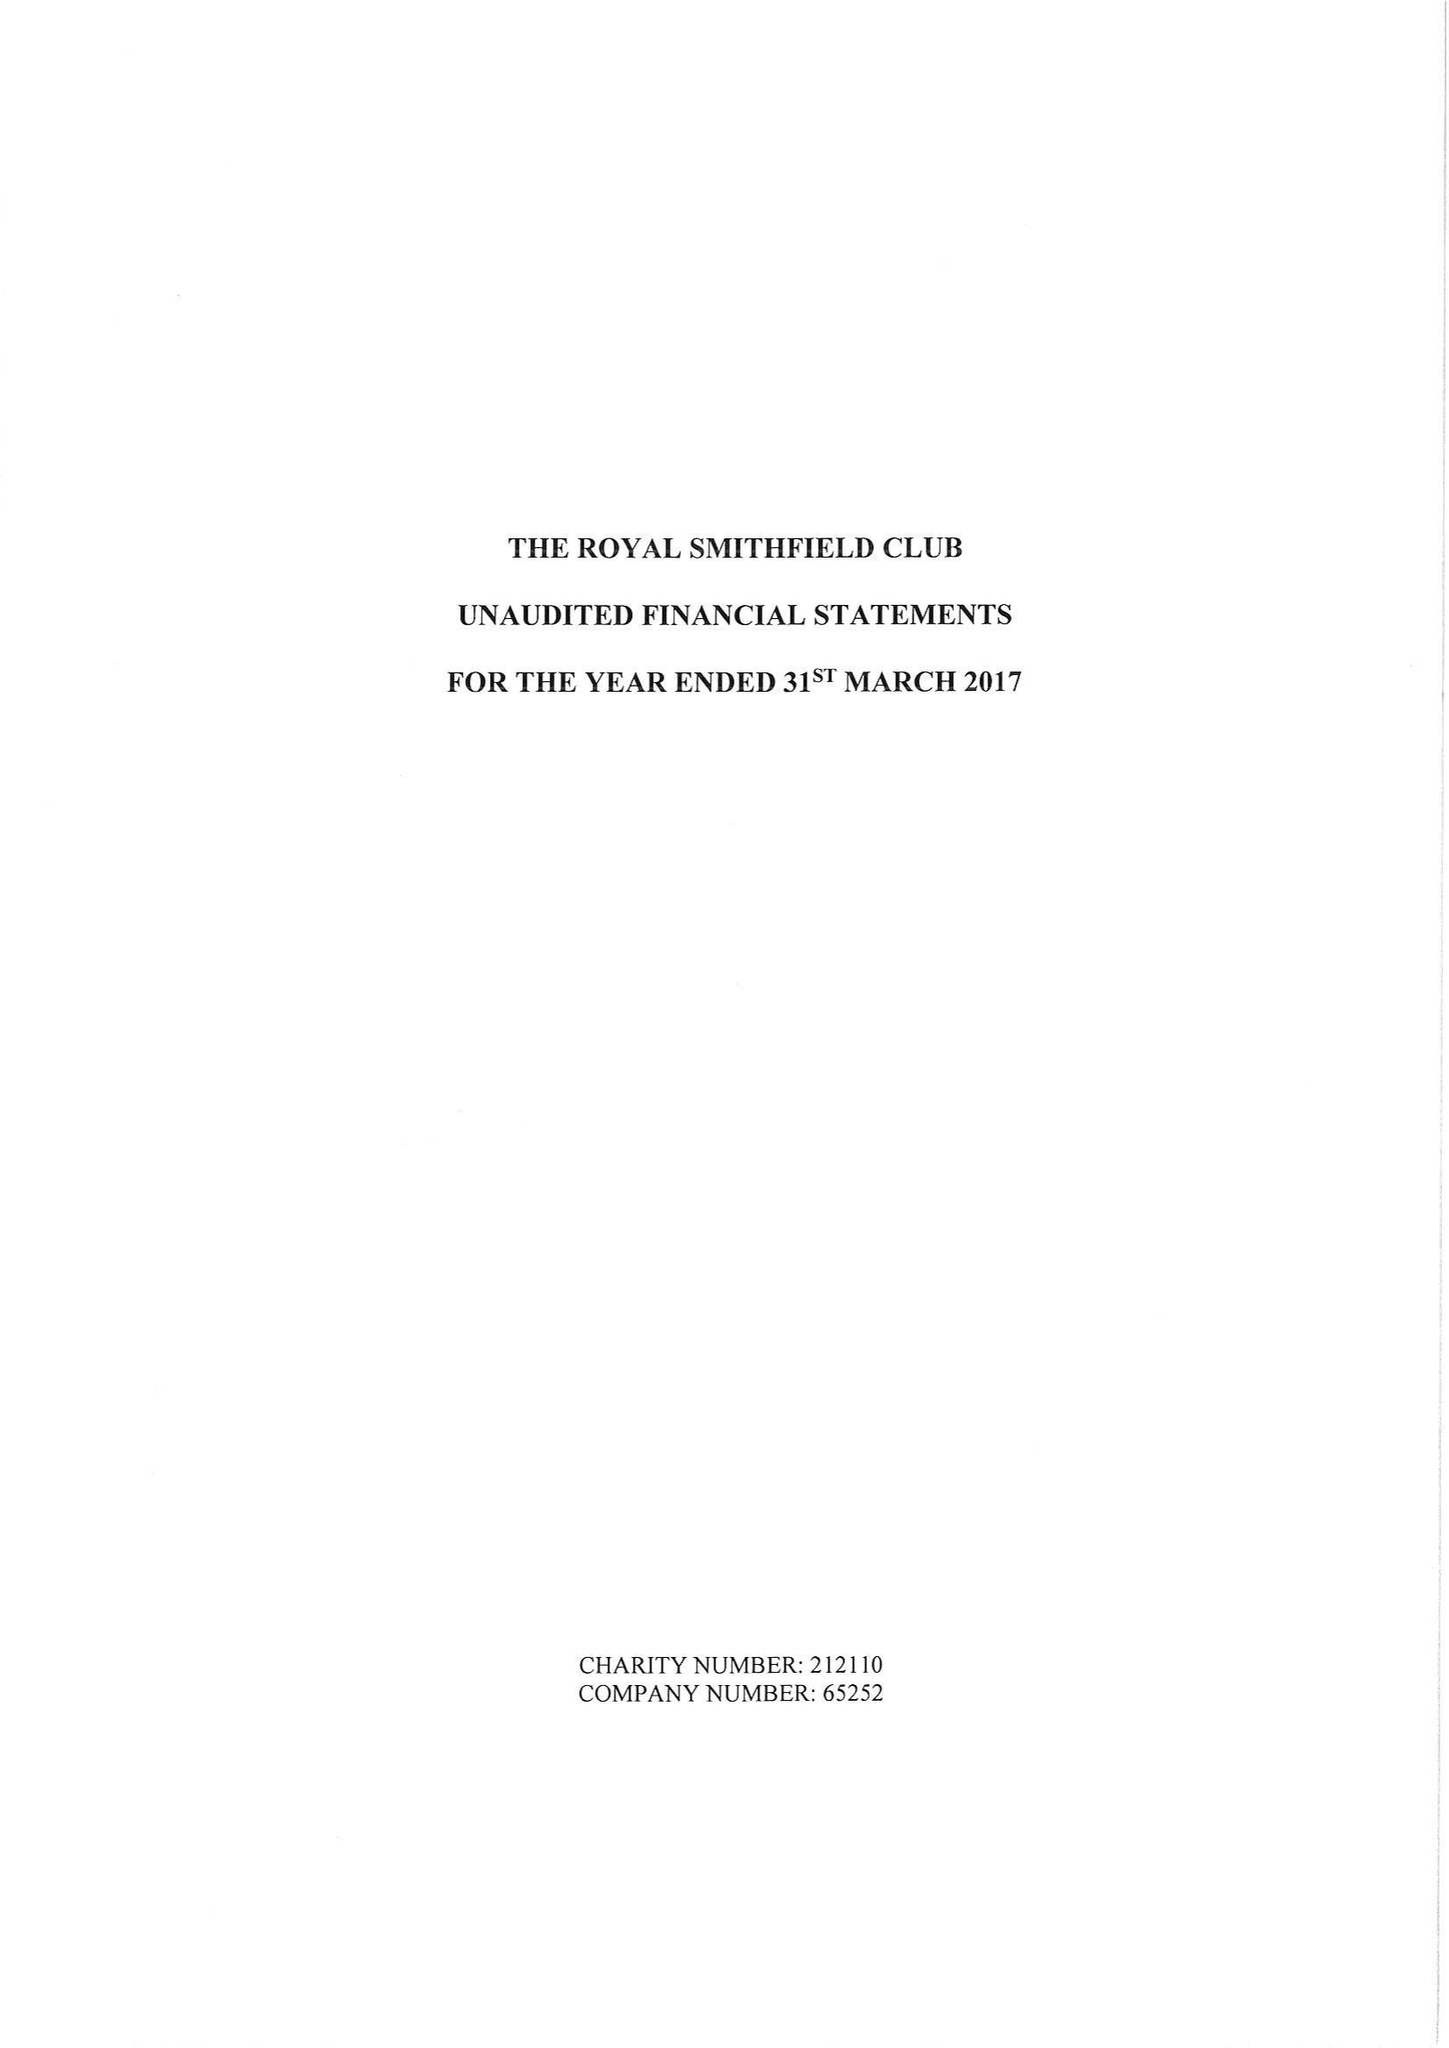What is the value for the address__post_town?
Answer the question using a single word or phrase. TROWBRIDGE 